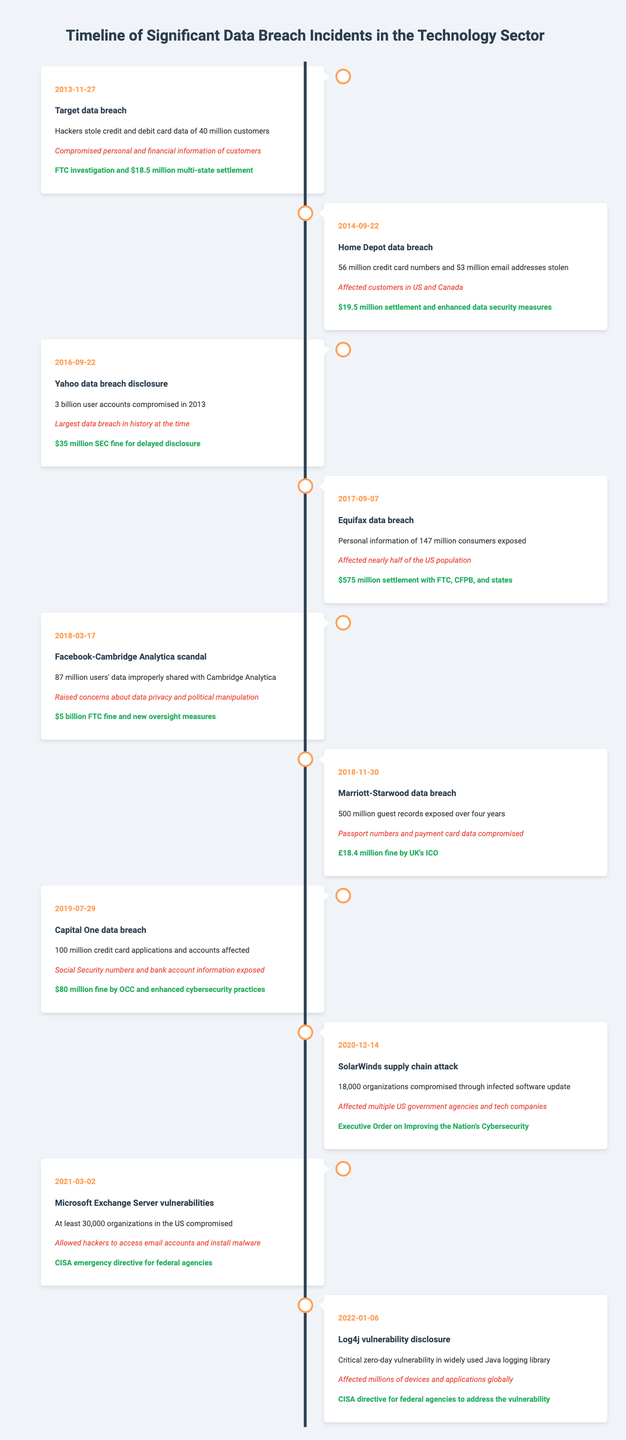What was the date of the Equifax data breach? The Equifax data breach occurred on September 7, 2017, as noted in the table.
Answer: September 7, 2017 How many user accounts were compromised in the Yahoo data breach? The table indicates that 3 billion user accounts were compromised in the Yahoo data breach disclosed on September 22, 2016.
Answer: 3 billion Which data breach incident had the highest regulatory fine? The Facebook-Cambridge Analytica scandal on March 17, 2018, had the highest regulatory fine of $5 billion.
Answer: $5 billion Was the Target data breach related to personal and financial information? Yes, the description of the Target data breach mentions the compromised personal and financial information of customers.
Answer: Yes What is the total number of guests whose records were exposed in the Marriott-Starwood data breach? The table states that 500 million guest records were exposed over four years during the Marriott-Starwood data breach on November 30, 2018.
Answer: 500 million How many breaches had a settlement amount exceeding $100 million? Only the Equifax data breach had a settlement amount of $575 million, thus the count of breaches with settlements exceeding $100 million is one.
Answer: 1 What impact did the SolarWinds supply chain attack have? The SolarWinds attack affected 18,000 organizations, including multiple U.S. government agencies and tech companies, according to the event description.
Answer: 18,000 organizations Which two incidents involved compromised login information? The Yahoo data breach was associated with compromised user accounts, and the Microsoft Exchange Server vulnerabilities allowed access to email accounts. Both incidents involved login information being compromised.
Answer: Yahoo and Microsoft Exchange Server What was the average financial settlement amount from the breaches in the table? Adding the settlement amounts: (18.5 + 19.5 + 35 + 575 + 5 + 18.4 + 80) million equals 736.4 million. Dividing this by the 7 breaches that had settlements gives an average of approximately 105.2 million.
Answer: 105.2 million How many of the incidents affected U.S. customers? The Home Depot, Equifax, Capital One, and the SolarWinds incidents explicitly state or imply affected U.S. customers, totaling four incidents.
Answer: 4 